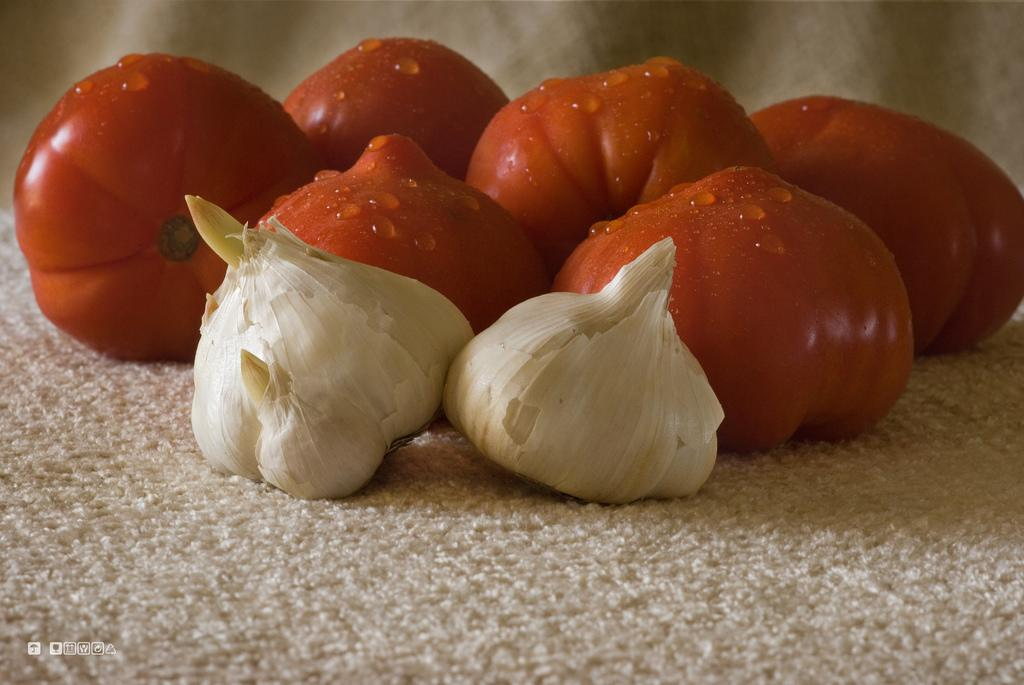What types of vegetables are in the image? There are garlic and tomatoes in the image. How are the garlic and tomatoes arranged or placed? The garlic and tomatoes are placed on a white cloth. Is there any additional element present in the image? Yes, there is a watermark on the left side of the image. Where is the faucet located in the image? There is no faucet present in the image. What type of fruit is placed next to the garlic and tomatoes in the image? There is no fruit, specifically a banana, present in the image. 